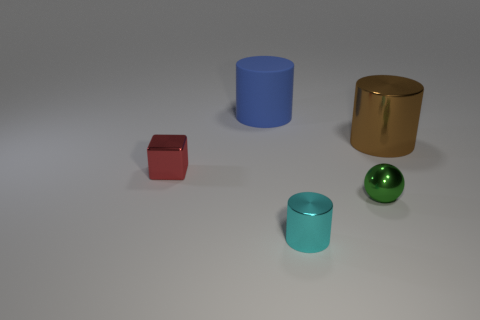What is the material of the blue cylinder that is the same size as the brown cylinder?
Offer a very short reply. Rubber. What number of metal things are either green balls or large brown cylinders?
Make the answer very short. 2. Is the number of brown metal cylinders behind the big brown thing the same as the number of tiny cyan metallic blocks?
Your response must be concise. Yes. There is a thing that is both behind the small metallic cube and left of the cyan shiny thing; what material is it made of?
Give a very brief answer. Rubber. Are there any brown metal things left of the cylinder in front of the cube?
Make the answer very short. No. Does the red cube have the same material as the green sphere?
Your answer should be very brief. Yes. What is the shape of the small metal object that is on the left side of the green sphere and behind the small shiny cylinder?
Provide a short and direct response. Cube. There is a metal cylinder in front of the shiny object that is behind the small red cube; what size is it?
Your answer should be very brief. Small. What number of cyan things are the same shape as the blue matte thing?
Keep it short and to the point. 1. Is the color of the large matte thing the same as the ball?
Provide a succinct answer. No. 